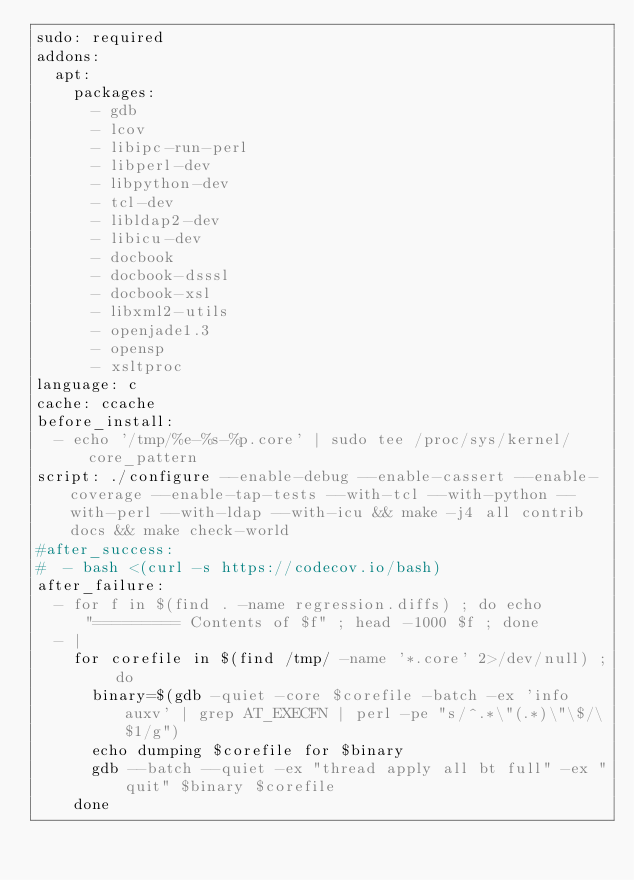<code> <loc_0><loc_0><loc_500><loc_500><_YAML_>sudo: required
addons:
  apt:
    packages:
      - gdb
      - lcov
      - libipc-run-perl
      - libperl-dev
      - libpython-dev
      - tcl-dev
      - libldap2-dev
      - libicu-dev
      - docbook
      - docbook-dsssl
      - docbook-xsl
      - libxml2-utils
      - openjade1.3
      - opensp
      - xsltproc
language: c
cache: ccache
before_install:
  - echo '/tmp/%e-%s-%p.core' | sudo tee /proc/sys/kernel/core_pattern
script: ./configure --enable-debug --enable-cassert --enable-coverage --enable-tap-tests --with-tcl --with-python --with-perl --with-ldap --with-icu && make -j4 all contrib docs && make check-world
#after_success:
#  - bash <(curl -s https://codecov.io/bash)
after_failure:
  - for f in $(find . -name regression.diffs) ; do echo "========= Contents of $f" ; head -1000 $f ; done
  - |
    for corefile in $(find /tmp/ -name '*.core' 2>/dev/null) ; do
      binary=$(gdb -quiet -core $corefile -batch -ex 'info auxv' | grep AT_EXECFN | perl -pe "s/^.*\"(.*)\"\$/\$1/g")
      echo dumping $corefile for $binary
      gdb --batch --quiet -ex "thread apply all bt full" -ex "quit" $binary $corefile
    done
</code> 